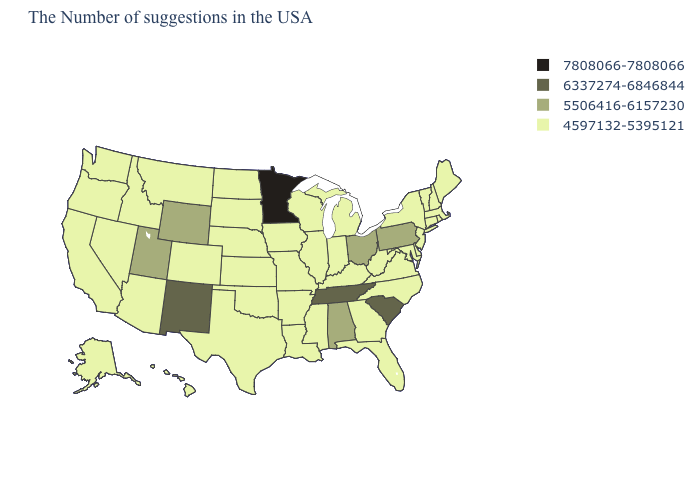What is the highest value in the USA?
Be succinct. 7808066-7808066. What is the value of South Carolina?
Keep it brief. 6337274-6846844. Among the states that border Vermont , which have the lowest value?
Write a very short answer. Massachusetts, New Hampshire, New York. Which states have the highest value in the USA?
Give a very brief answer. Minnesota. Among the states that border South Carolina , which have the highest value?
Concise answer only. North Carolina, Georgia. What is the value of Florida?
Be succinct. 4597132-5395121. What is the value of Pennsylvania?
Answer briefly. 5506416-6157230. What is the value of Washington?
Short answer required. 4597132-5395121. Does New York have the lowest value in the Northeast?
Be succinct. Yes. Does Minnesota have the highest value in the USA?
Write a very short answer. Yes. Does Massachusetts have the lowest value in the Northeast?
Write a very short answer. Yes. What is the value of Arizona?
Short answer required. 4597132-5395121. What is the highest value in the USA?
Answer briefly. 7808066-7808066. What is the lowest value in the Northeast?
Write a very short answer. 4597132-5395121. What is the highest value in the USA?
Concise answer only. 7808066-7808066. 